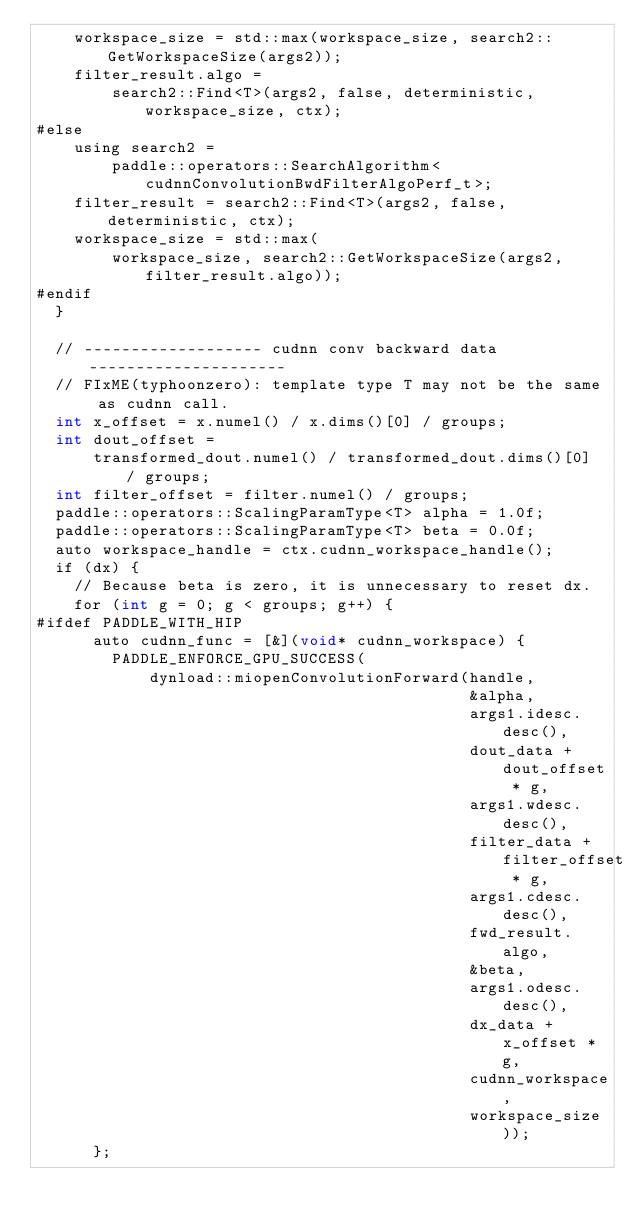<code> <loc_0><loc_0><loc_500><loc_500><_Cuda_>    workspace_size = std::max(workspace_size, search2::GetWorkspaceSize(args2));
    filter_result.algo =
        search2::Find<T>(args2, false, deterministic, workspace_size, ctx);
#else
    using search2 =
        paddle::operators::SearchAlgorithm<cudnnConvolutionBwdFilterAlgoPerf_t>;
    filter_result = search2::Find<T>(args2, false, deterministic, ctx);
    workspace_size = std::max(
        workspace_size, search2::GetWorkspaceSize(args2, filter_result.algo));
#endif
  }

  // ------------------- cudnn conv backward data ---------------------
  // FIxME(typhoonzero): template type T may not be the same as cudnn call.
  int x_offset = x.numel() / x.dims()[0] / groups;
  int dout_offset =
      transformed_dout.numel() / transformed_dout.dims()[0] / groups;
  int filter_offset = filter.numel() / groups;
  paddle::operators::ScalingParamType<T> alpha = 1.0f;
  paddle::operators::ScalingParamType<T> beta = 0.0f;
  auto workspace_handle = ctx.cudnn_workspace_handle();
  if (dx) {
    // Because beta is zero, it is unnecessary to reset dx.
    for (int g = 0; g < groups; g++) {
#ifdef PADDLE_WITH_HIP
      auto cudnn_func = [&](void* cudnn_workspace) {
        PADDLE_ENFORCE_GPU_SUCCESS(
            dynload::miopenConvolutionForward(handle,
                                              &alpha,
                                              args1.idesc.desc(),
                                              dout_data + dout_offset * g,
                                              args1.wdesc.desc(),
                                              filter_data + filter_offset * g,
                                              args1.cdesc.desc(),
                                              fwd_result.algo,
                                              &beta,
                                              args1.odesc.desc(),
                                              dx_data + x_offset * g,
                                              cudnn_workspace,
                                              workspace_size));
      };</code> 